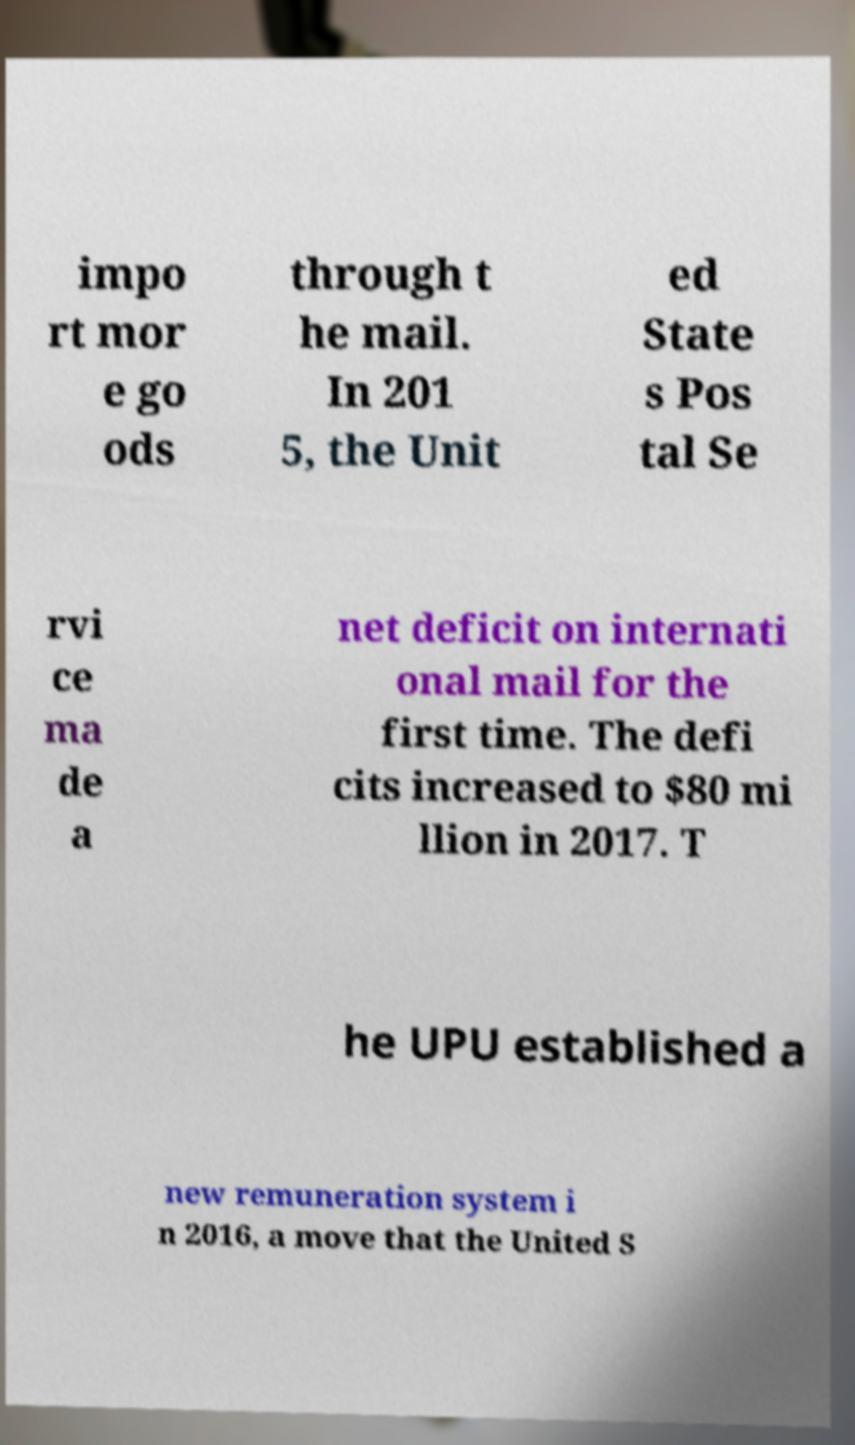Please read and relay the text visible in this image. What does it say? impo rt mor e go ods through t he mail. In 201 5, the Unit ed State s Pos tal Se rvi ce ma de a net deficit on internati onal mail for the first time. The defi cits increased to $80 mi llion in 2017. T he UPU established a new remuneration system i n 2016, a move that the United S 